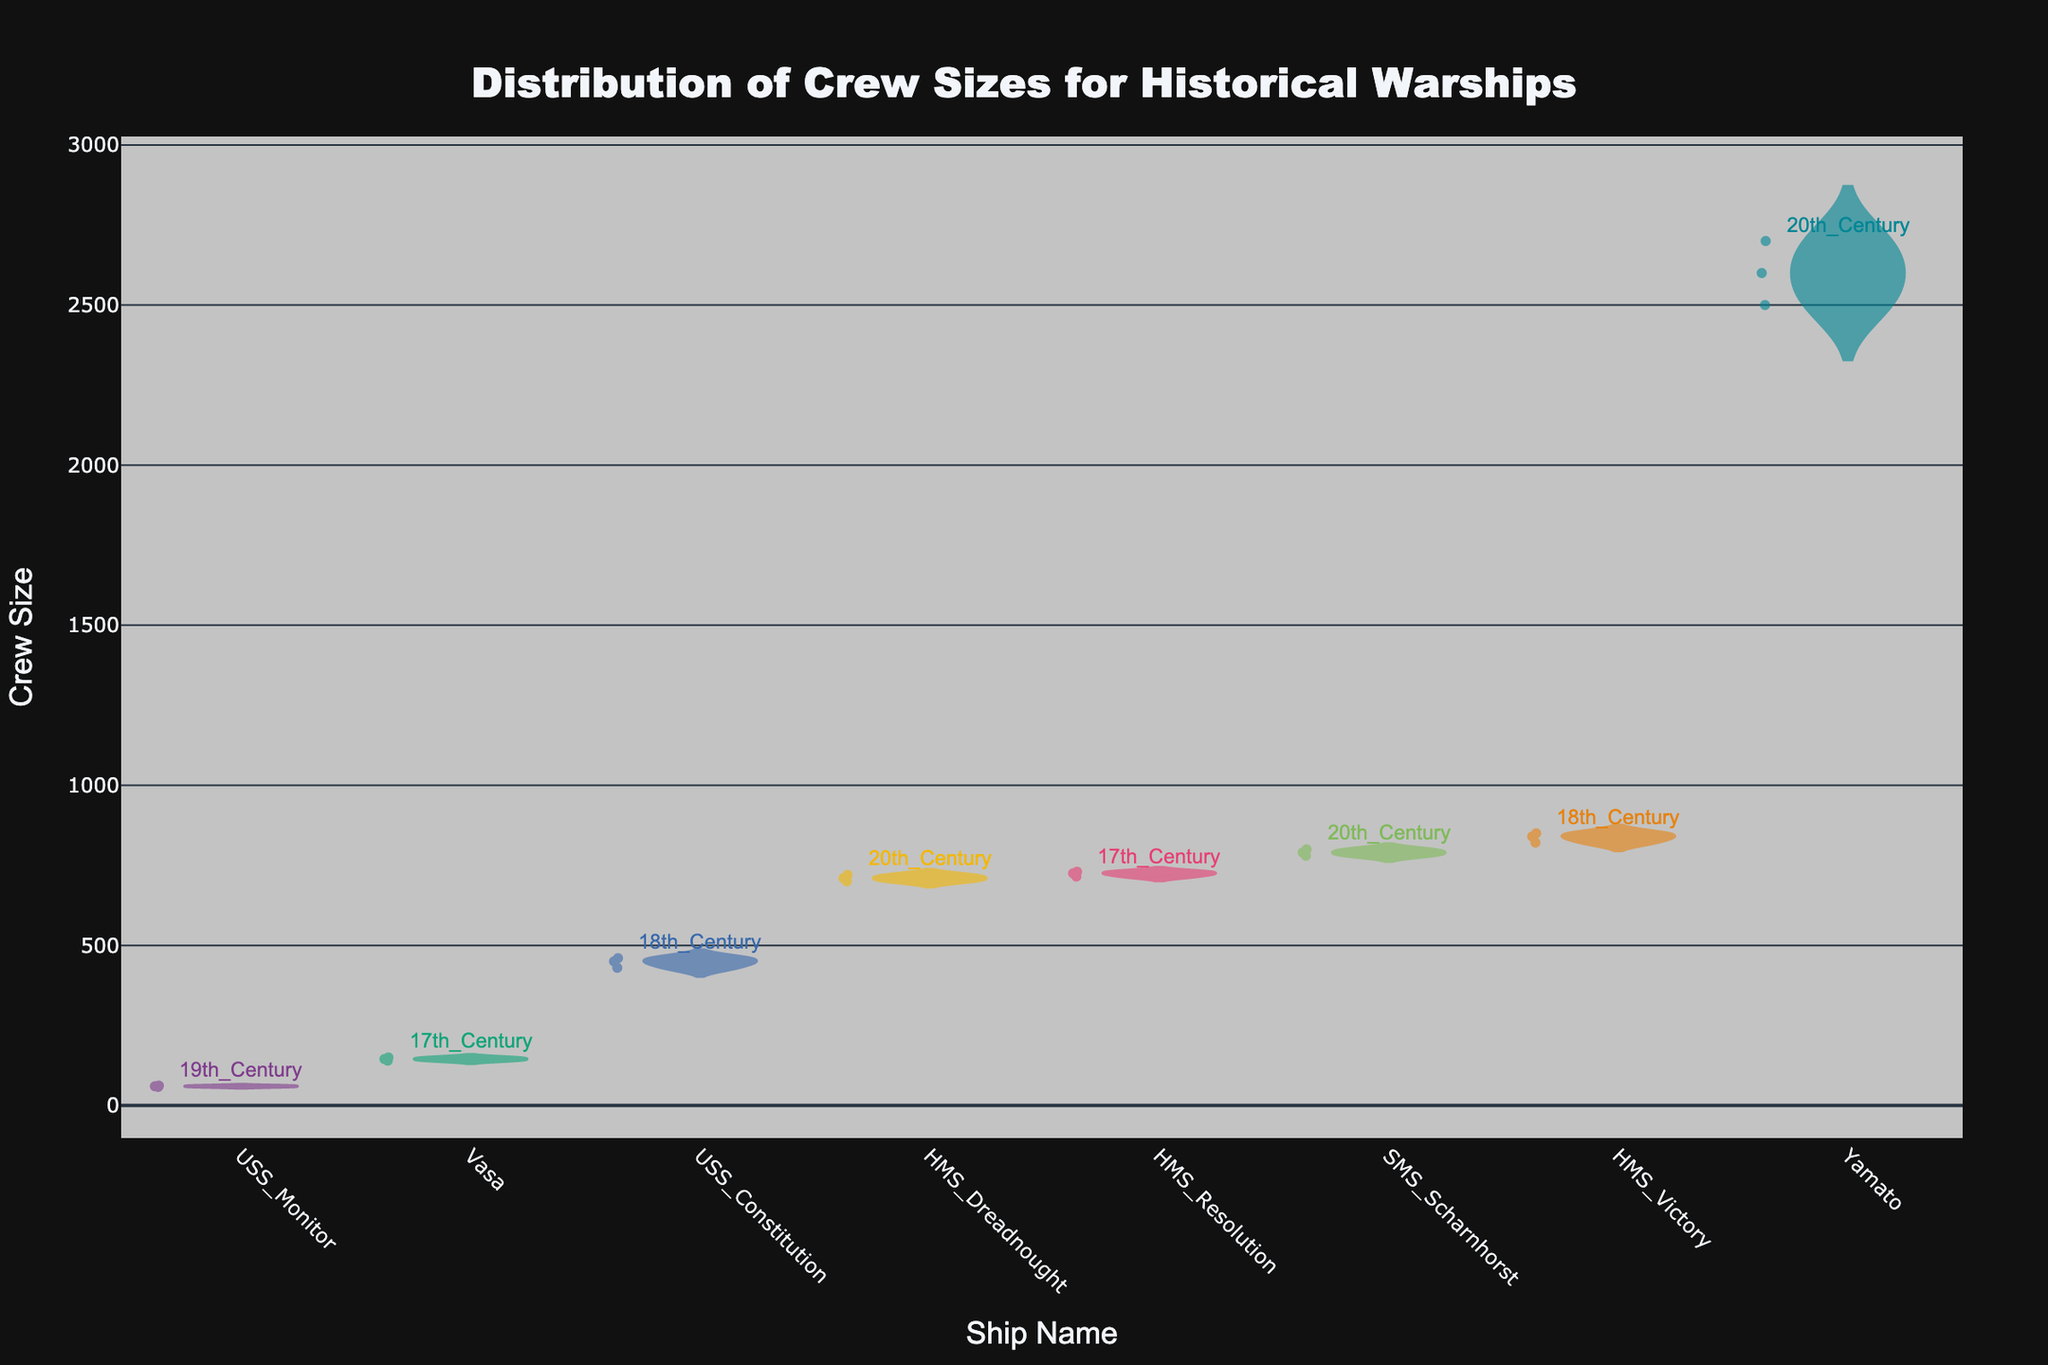How many different historical warships are represented in the figure? To determine the number of different historical warships, we count the unique ship names along the x-axis of the figure. Each violin represents a distinct ship.
Answer: 7 Which ship has the largest range in crew sizes? The range in crew sizes for each ship can be visually identified by the height of the violin plot. The ship with the tallest violin plot has the largest range.
Answer: Yamato What is the crew size of HMS Victory during the 18th Century? By looking at the points scattered across the violin for HMS Victory, we can identify the crew sizes, which are close to 821, 850, and 840.
Answer: Around 850 Which ship from the 20th Century has the highest average crew size? By comparing the mean lines (horizontal lines) within the violins for the ships from the 20th Century, the ship with the highest mean line corresponds to the highest average crew size.
Answer: Yamato Compare the average crew size of USS Monitor in the 19th Century to Vasa in the 17th Century. Which one is larger? By analyzing the mean lines within the violins for USS Monitor and Vasa, we can compare their positions. The higher mean line indicates a larger average crew size.
Answer: Vasa What's the total number of crew sizes reported for the 20th Century ships? Count the data points (jittered points) within the violins corresponding to the 20th Century ships: HMS Dreadnought, SMS Scharnhorst, and Yamato.
Answer: 9 Which ship has the smallest crew size reported? Identify the violin with the lowest point on the y-axis.
Answer: USS Monitor What is the period of HMS Resolution? Look for the period annotation above the violin representing HMS Resolution.
Answer: 17th Century Is there any ship from the 18th Century with a crew size larger than any ship from the 17th Century? Compare the highest points in the 18th Century ships' violins (HMS Victory and USS Constitution) with the highest points in the 17th Century ships' violins (Vasa and HMS Resolution).
Answer: Yes 